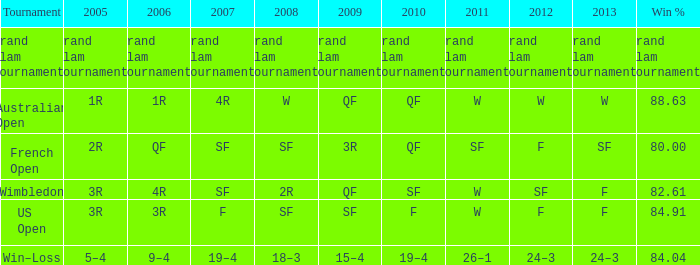What in 2013 has a 2009 of 3r? SF. 